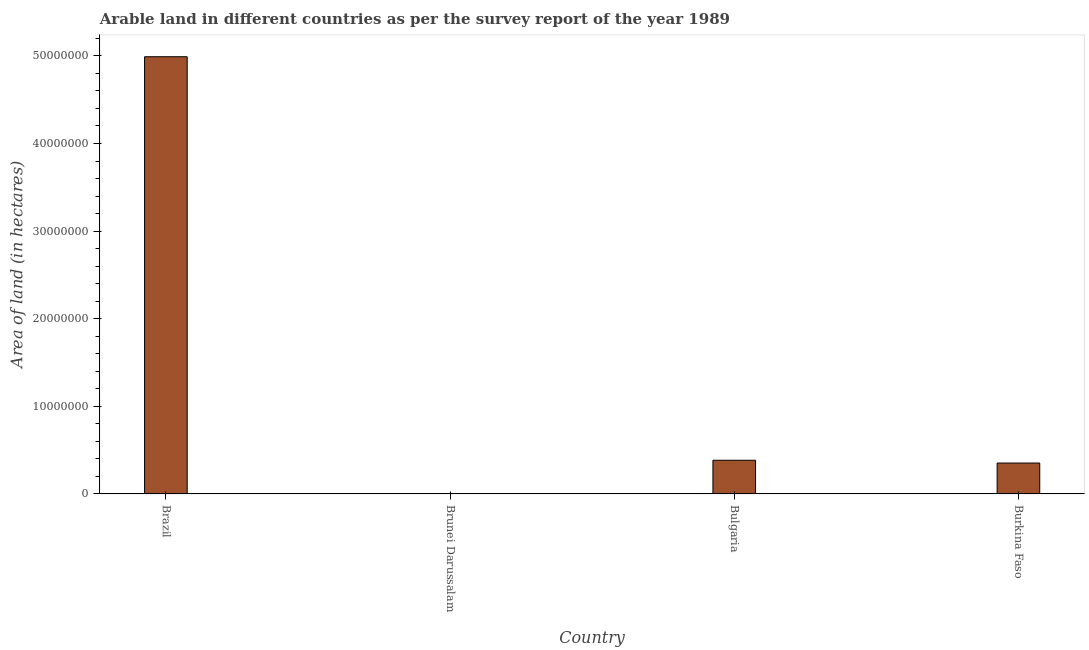Does the graph contain any zero values?
Provide a succinct answer. No. What is the title of the graph?
Make the answer very short. Arable land in different countries as per the survey report of the year 1989. What is the label or title of the X-axis?
Make the answer very short. Country. What is the label or title of the Y-axis?
Offer a terse response. Area of land (in hectares). What is the area of land in Burkina Faso?
Keep it short and to the point. 3.53e+06. Across all countries, what is the maximum area of land?
Provide a short and direct response. 4.99e+07. Across all countries, what is the minimum area of land?
Ensure brevity in your answer.  3000. In which country was the area of land minimum?
Your answer should be compact. Brunei Darussalam. What is the sum of the area of land?
Offer a terse response. 5.73e+07. What is the difference between the area of land in Brunei Darussalam and Burkina Faso?
Offer a terse response. -3.53e+06. What is the average area of land per country?
Your answer should be very brief. 1.43e+07. What is the median area of land?
Offer a very short reply. 3.69e+06. In how many countries, is the area of land greater than 30000000 hectares?
Ensure brevity in your answer.  1. Is the area of land in Bulgaria less than that in Burkina Faso?
Make the answer very short. No. Is the difference between the area of land in Brunei Darussalam and Burkina Faso greater than the difference between any two countries?
Make the answer very short. No. What is the difference between the highest and the second highest area of land?
Ensure brevity in your answer.  4.61e+07. What is the difference between the highest and the lowest area of land?
Your answer should be compact. 4.99e+07. In how many countries, is the area of land greater than the average area of land taken over all countries?
Keep it short and to the point. 1. How many bars are there?
Give a very brief answer. 4. Are all the bars in the graph horizontal?
Your answer should be very brief. No. How many countries are there in the graph?
Offer a very short reply. 4. What is the Area of land (in hectares) of Brazil?
Offer a very short reply. 4.99e+07. What is the Area of land (in hectares) in Brunei Darussalam?
Your answer should be compact. 3000. What is the Area of land (in hectares) of Bulgaria?
Ensure brevity in your answer.  3.85e+06. What is the Area of land (in hectares) of Burkina Faso?
Make the answer very short. 3.53e+06. What is the difference between the Area of land (in hectares) in Brazil and Brunei Darussalam?
Keep it short and to the point. 4.99e+07. What is the difference between the Area of land (in hectares) in Brazil and Bulgaria?
Your response must be concise. 4.61e+07. What is the difference between the Area of land (in hectares) in Brazil and Burkina Faso?
Offer a very short reply. 4.64e+07. What is the difference between the Area of land (in hectares) in Brunei Darussalam and Bulgaria?
Make the answer very short. -3.84e+06. What is the difference between the Area of land (in hectares) in Brunei Darussalam and Burkina Faso?
Make the answer very short. -3.53e+06. What is the difference between the Area of land (in hectares) in Bulgaria and Burkina Faso?
Make the answer very short. 3.18e+05. What is the ratio of the Area of land (in hectares) in Brazil to that in Brunei Darussalam?
Provide a succinct answer. 1.66e+04. What is the ratio of the Area of land (in hectares) in Brazil to that in Bulgaria?
Offer a very short reply. 12.97. What is the ratio of the Area of land (in hectares) in Brazil to that in Burkina Faso?
Offer a terse response. 14.14. What is the ratio of the Area of land (in hectares) in Brunei Darussalam to that in Bulgaria?
Offer a very short reply. 0. What is the ratio of the Area of land (in hectares) in Brunei Darussalam to that in Burkina Faso?
Provide a short and direct response. 0. What is the ratio of the Area of land (in hectares) in Bulgaria to that in Burkina Faso?
Provide a short and direct response. 1.09. 